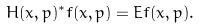Convert formula to latex. <formula><loc_0><loc_0><loc_500><loc_500>H ( x , p ) ^ { * } f ( x , p ) = E f ( x , p ) .</formula> 